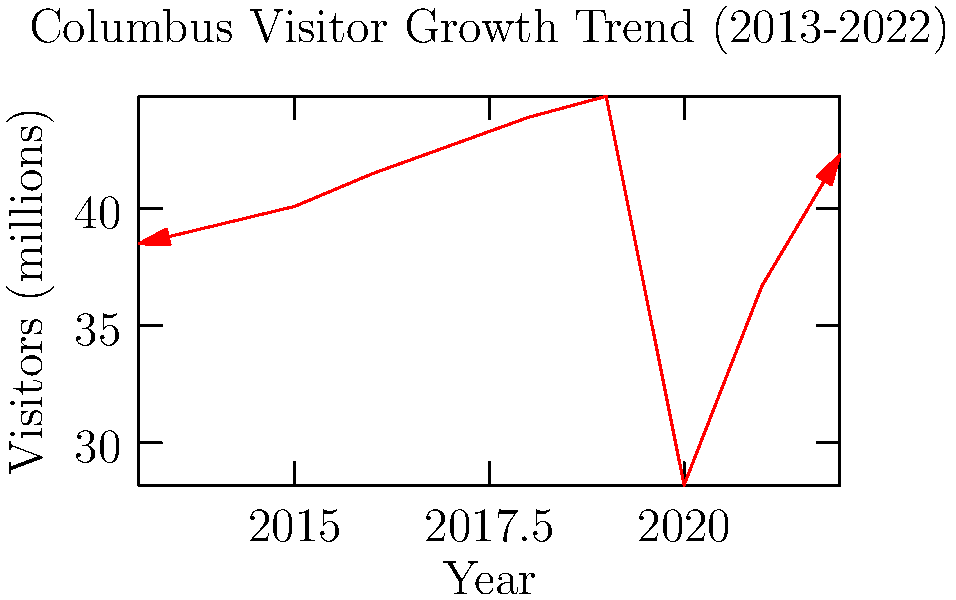Based on the line graph showing Columbus visitor growth from 2013 to 2022, which year experienced the most significant drop in visitor numbers, and what could be a potential explanation for this sudden decline? To answer this question, let's analyze the graph step-by-step:

1. Examine the overall trend: The graph shows a generally increasing trend in visitor numbers from 2013 to 2019.

2. Identify the anomaly: There's a sharp decline visible between 2019 and 2020.

3. Quantify the drop:
   - 2019 visitors: approximately 44.8 million
   - 2020 visitors: approximately 28.2 million
   - Decrease: 44.8 - 28.2 = 16.6 million visitors

4. Compare with other years: No other year shows such a dramatic decrease.

5. Consider potential explanations: The year 2020 coincides with the onset of the COVID-19 pandemic, which severely impacted global travel and tourism.

6. Observe the recovery: There's an upward trend after 2020, suggesting a gradual recovery in visitor numbers.

Therefore, 2020 experienced the most significant drop in visitor numbers, likely due to the COVID-19 pandemic and associated travel restrictions.
Answer: 2020, due to COVID-19 pandemic 